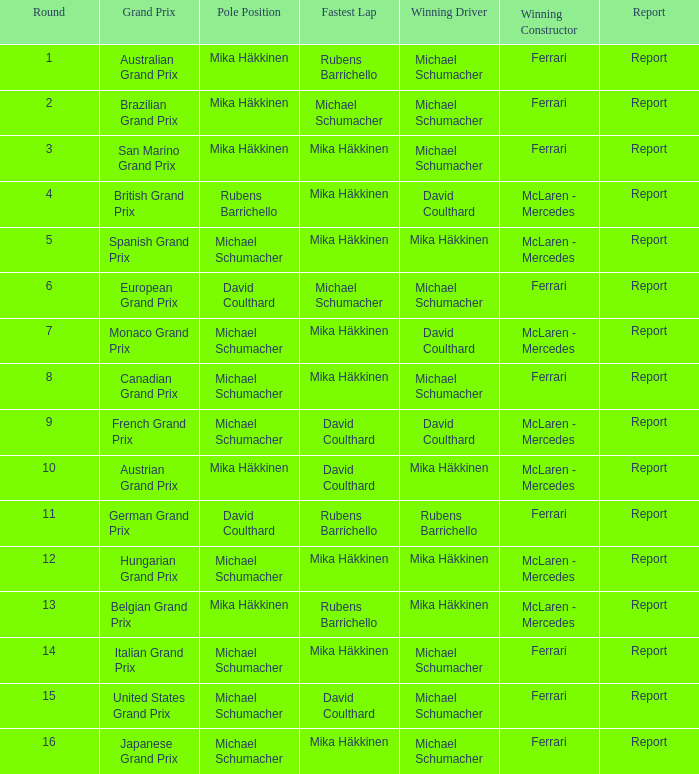What was the summary of the belgian grand prix? Report. 